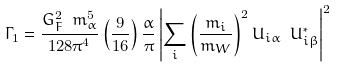Convert formula to latex. <formula><loc_0><loc_0><loc_500><loc_500>\Gamma _ { 1 } = \frac { G ^ { 2 } _ { F } \ m _ { \alpha } ^ { 5 } } { 1 2 8 \pi ^ { 4 } } \left ( \frac { 9 } { 1 6 } \right ) \frac { \alpha } { \pi } \left | \sum _ { i } \left ( \frac { m _ { i } } { m _ { W } } \right ) ^ { 2 } U _ { i \alpha } \ U ^ { * } _ { i \beta } \right | ^ { 2 }</formula> 